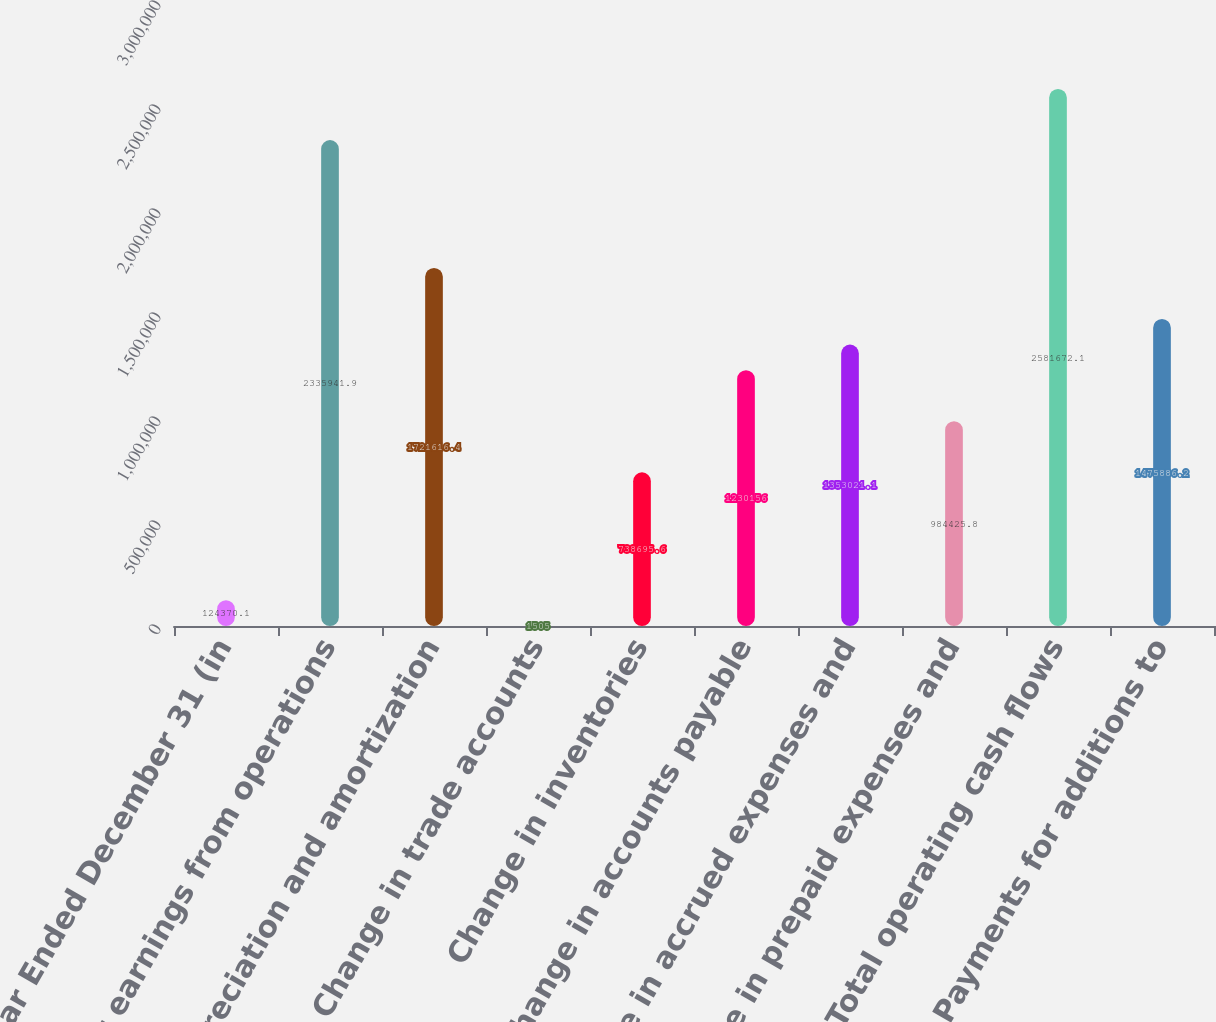Convert chart to OTSL. <chart><loc_0><loc_0><loc_500><loc_500><bar_chart><fcel>Year Ended December 31 (in<fcel>Net earnings from operations<fcel>Depreciation and amortization<fcel>Change in trade accounts<fcel>Change in inventories<fcel>Change in accounts payable<fcel>Change in accrued expenses and<fcel>Change in prepaid expenses and<fcel>Total operating cash flows<fcel>Payments for additions to<nl><fcel>124370<fcel>2.33594e+06<fcel>1.72162e+06<fcel>1505<fcel>738696<fcel>1.23016e+06<fcel>1.35302e+06<fcel>984426<fcel>2.58167e+06<fcel>1.47589e+06<nl></chart> 